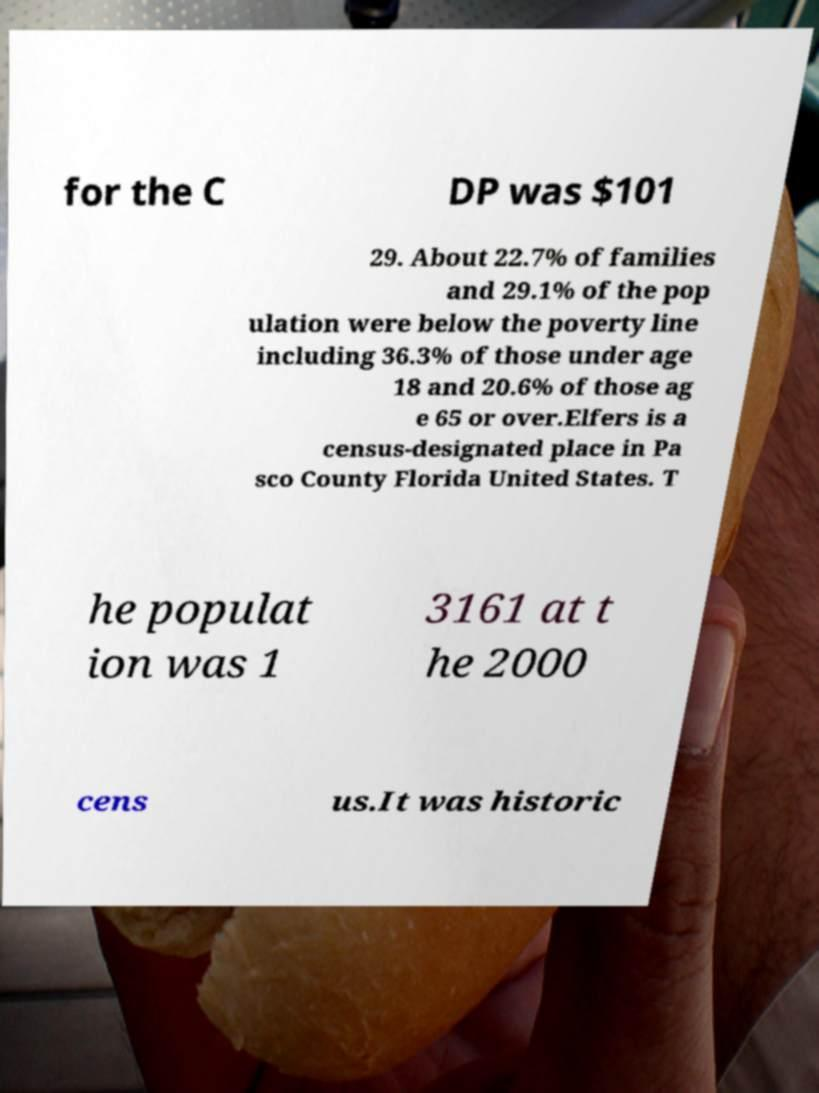What messages or text are displayed in this image? I need them in a readable, typed format. for the C DP was $101 29. About 22.7% of families and 29.1% of the pop ulation were below the poverty line including 36.3% of those under age 18 and 20.6% of those ag e 65 or over.Elfers is a census-designated place in Pa sco County Florida United States. T he populat ion was 1 3161 at t he 2000 cens us.It was historic 